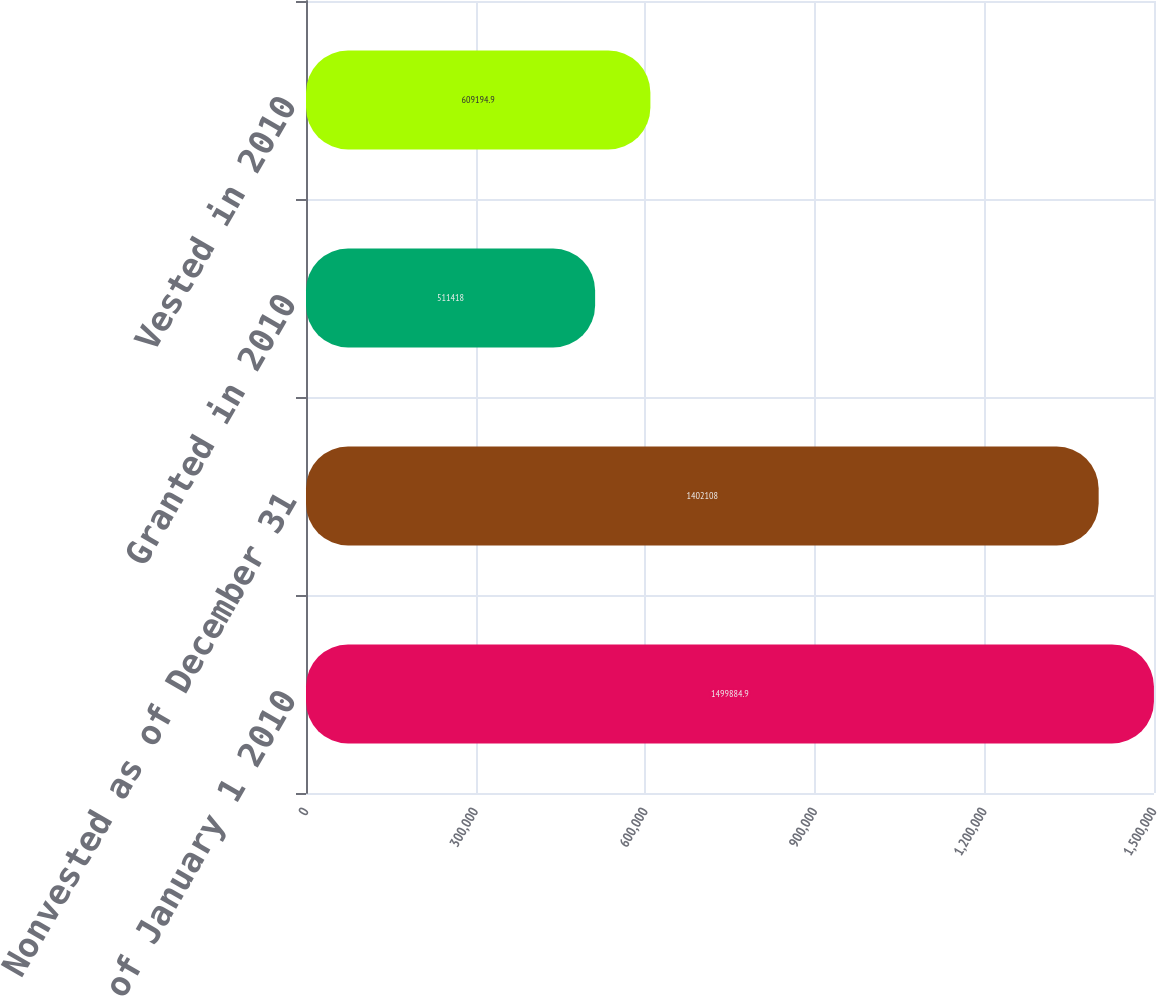<chart> <loc_0><loc_0><loc_500><loc_500><bar_chart><fcel>Nonvested as of January 1 2010<fcel>Nonvested as of December 31<fcel>Granted in 2010<fcel>Vested in 2010<nl><fcel>1.49988e+06<fcel>1.40211e+06<fcel>511418<fcel>609195<nl></chart> 